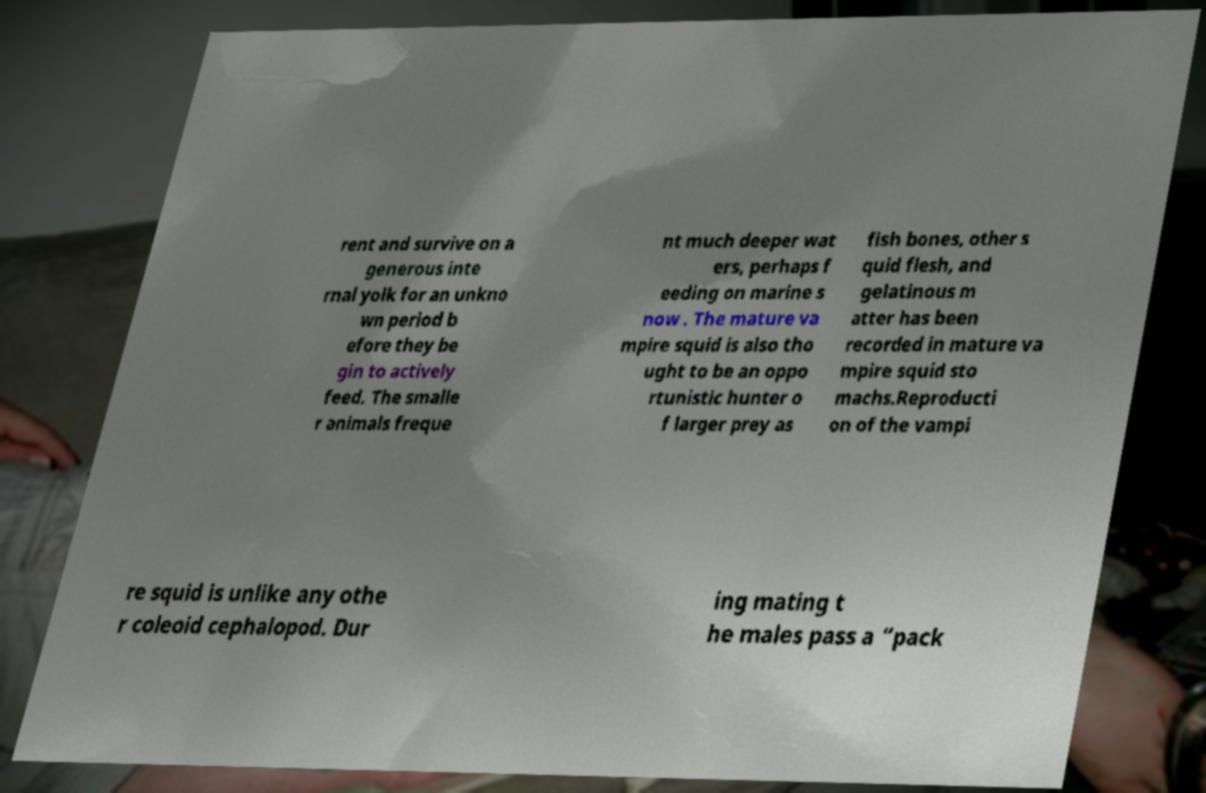Could you assist in decoding the text presented in this image and type it out clearly? rent and survive on a generous inte rnal yolk for an unkno wn period b efore they be gin to actively feed. The smalle r animals freque nt much deeper wat ers, perhaps f eeding on marine s now . The mature va mpire squid is also tho ught to be an oppo rtunistic hunter o f larger prey as fish bones, other s quid flesh, and gelatinous m atter has been recorded in mature va mpire squid sto machs.Reproducti on of the vampi re squid is unlike any othe r coleoid cephalopod. Dur ing mating t he males pass a “pack 